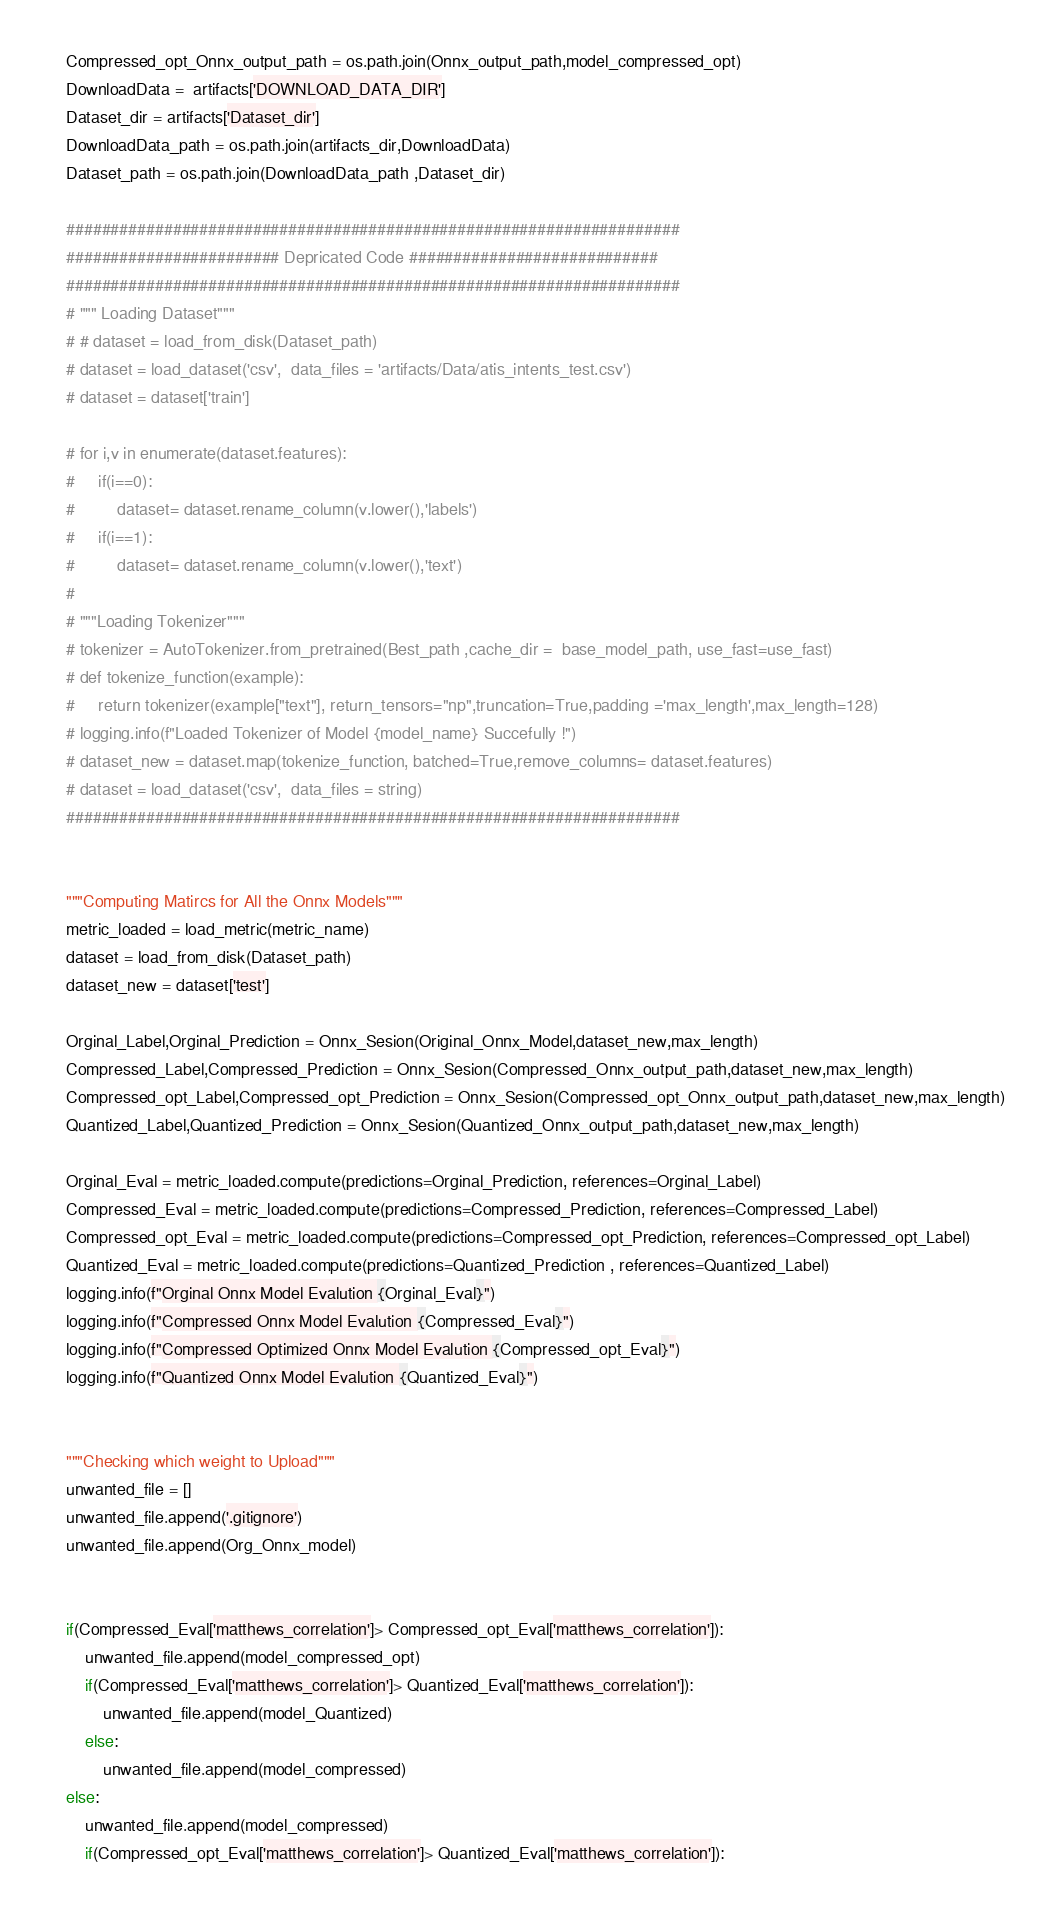<code> <loc_0><loc_0><loc_500><loc_500><_Python_>    Compressed_opt_Onnx_output_path = os.path.join(Onnx_output_path,model_compressed_opt)    
    DownloadData =  artifacts['DOWNLOAD_DATA_DIR']
    Dataset_dir = artifacts['Dataset_dir']
    DownloadData_path = os.path.join(artifacts_dir,DownloadData)   
    Dataset_path = os.path.join(DownloadData_path ,Dataset_dir)
    
    #####################################################################
    ######################## Depricated Code ############################
    #####################################################################
    # """ Loading Dataset"""
    # # dataset = load_from_disk(Dataset_path)
    # dataset = load_dataset('csv',  data_files = 'artifacts/Data/atis_intents_test.csv')
    # dataset = dataset['train']
    
    # for i,v in enumerate(dataset.features):
    #     if(i==0):
    #         dataset= dataset.rename_column(v.lower(),'labels')
    #     if(i==1):
    #         dataset= dataset.rename_column(v.lower(),'text')
    #   
    # """Loading Tokenizer"""
    # tokenizer = AutoTokenizer.from_pretrained(Best_path ,cache_dir =  base_model_path, use_fast=use_fast)
    # def tokenize_function(example):
    #     return tokenizer(example["text"], return_tensors="np",truncation=True,padding ='max_length',max_length=128) 
    # logging.info(f"Loaded Tokenizer of Model {model_name} Succefully !")
    # dataset_new = dataset.map(tokenize_function, batched=True,remove_columns= dataset.features)
    # dataset = load_dataset('csv',  data_files = string)
    #####################################################################
    
    
    """Computing Matircs for All the Onnx Models"""
    metric_loaded = load_metric(metric_name)
    dataset = load_from_disk(Dataset_path)
    dataset_new = dataset['test']
    
    Orginal_Label,Orginal_Prediction = Onnx_Sesion(Original_Onnx_Model,dataset_new,max_length)
    Compressed_Label,Compressed_Prediction = Onnx_Sesion(Compressed_Onnx_output_path,dataset_new,max_length)
    Compressed_opt_Label,Compressed_opt_Prediction = Onnx_Sesion(Compressed_opt_Onnx_output_path,dataset_new,max_length)
    Quantized_Label,Quantized_Prediction = Onnx_Sesion(Quantized_Onnx_output_path,dataset_new,max_length)
    
    Orginal_Eval = metric_loaded.compute(predictions=Orginal_Prediction, references=Orginal_Label)
    Compressed_Eval = metric_loaded.compute(predictions=Compressed_Prediction, references=Compressed_Label)
    Compressed_opt_Eval = metric_loaded.compute(predictions=Compressed_opt_Prediction, references=Compressed_opt_Label)
    Quantized_Eval = metric_loaded.compute(predictions=Quantized_Prediction , references=Quantized_Label)
    logging.info(f"Orginal Onnx Model Evalution {Orginal_Eval}")
    logging.info(f"Compressed Onnx Model Evalution {Compressed_Eval}")
    logging.info(f"Compressed Optimized Onnx Model Evalution {Compressed_opt_Eval}")
    logging.info(f"Quantized Onnx Model Evalution {Quantized_Eval}")
    
    
    """Checking which weight to Upload"""
    unwanted_file = []
    unwanted_file.append('.gitignore')
    unwanted_file.append(Org_Onnx_model)
     
    
    if(Compressed_Eval['matthews_correlation']> Compressed_opt_Eval['matthews_correlation']):
        unwanted_file.append(model_compressed_opt)
        if(Compressed_Eval['matthews_correlation']> Quantized_Eval['matthews_correlation']):
            unwanted_file.append(model_Quantized)  
        else:
            unwanted_file.append(model_compressed)                      
    else:
        unwanted_file.append(model_compressed)
        if(Compressed_opt_Eval['matthews_correlation']> Quantized_Eval['matthews_correlation']):</code> 